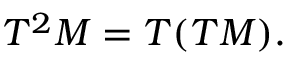Convert formula to latex. <formula><loc_0><loc_0><loc_500><loc_500>T ^ { 2 } M = T ( T M ) .</formula> 